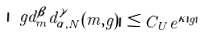Convert formula to latex. <formula><loc_0><loc_0><loc_500><loc_500>| \ g d _ { m } ^ { \beta } d ^ { \gamma } _ { \alpha , N } ( m , g ) | \leq C _ { U } e ^ { \kappa | g | }</formula> 